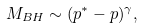<formula> <loc_0><loc_0><loc_500><loc_500>M _ { B H } \sim ( p ^ { * } - p ) ^ { \gamma } ,</formula> 